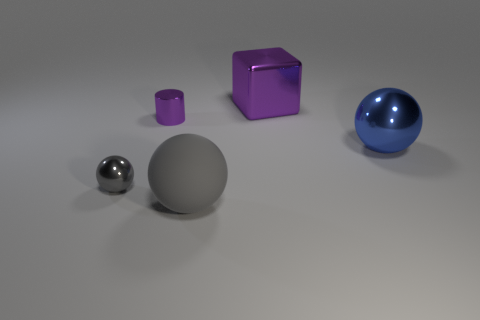Add 3 large rubber cubes. How many objects exist? 8 Subtract all blocks. How many objects are left? 4 Add 3 gray cylinders. How many gray cylinders exist? 3 Subtract 0 brown spheres. How many objects are left? 5 Subtract all big gray metallic objects. Subtract all tiny purple metallic cylinders. How many objects are left? 4 Add 5 purple cylinders. How many purple cylinders are left? 6 